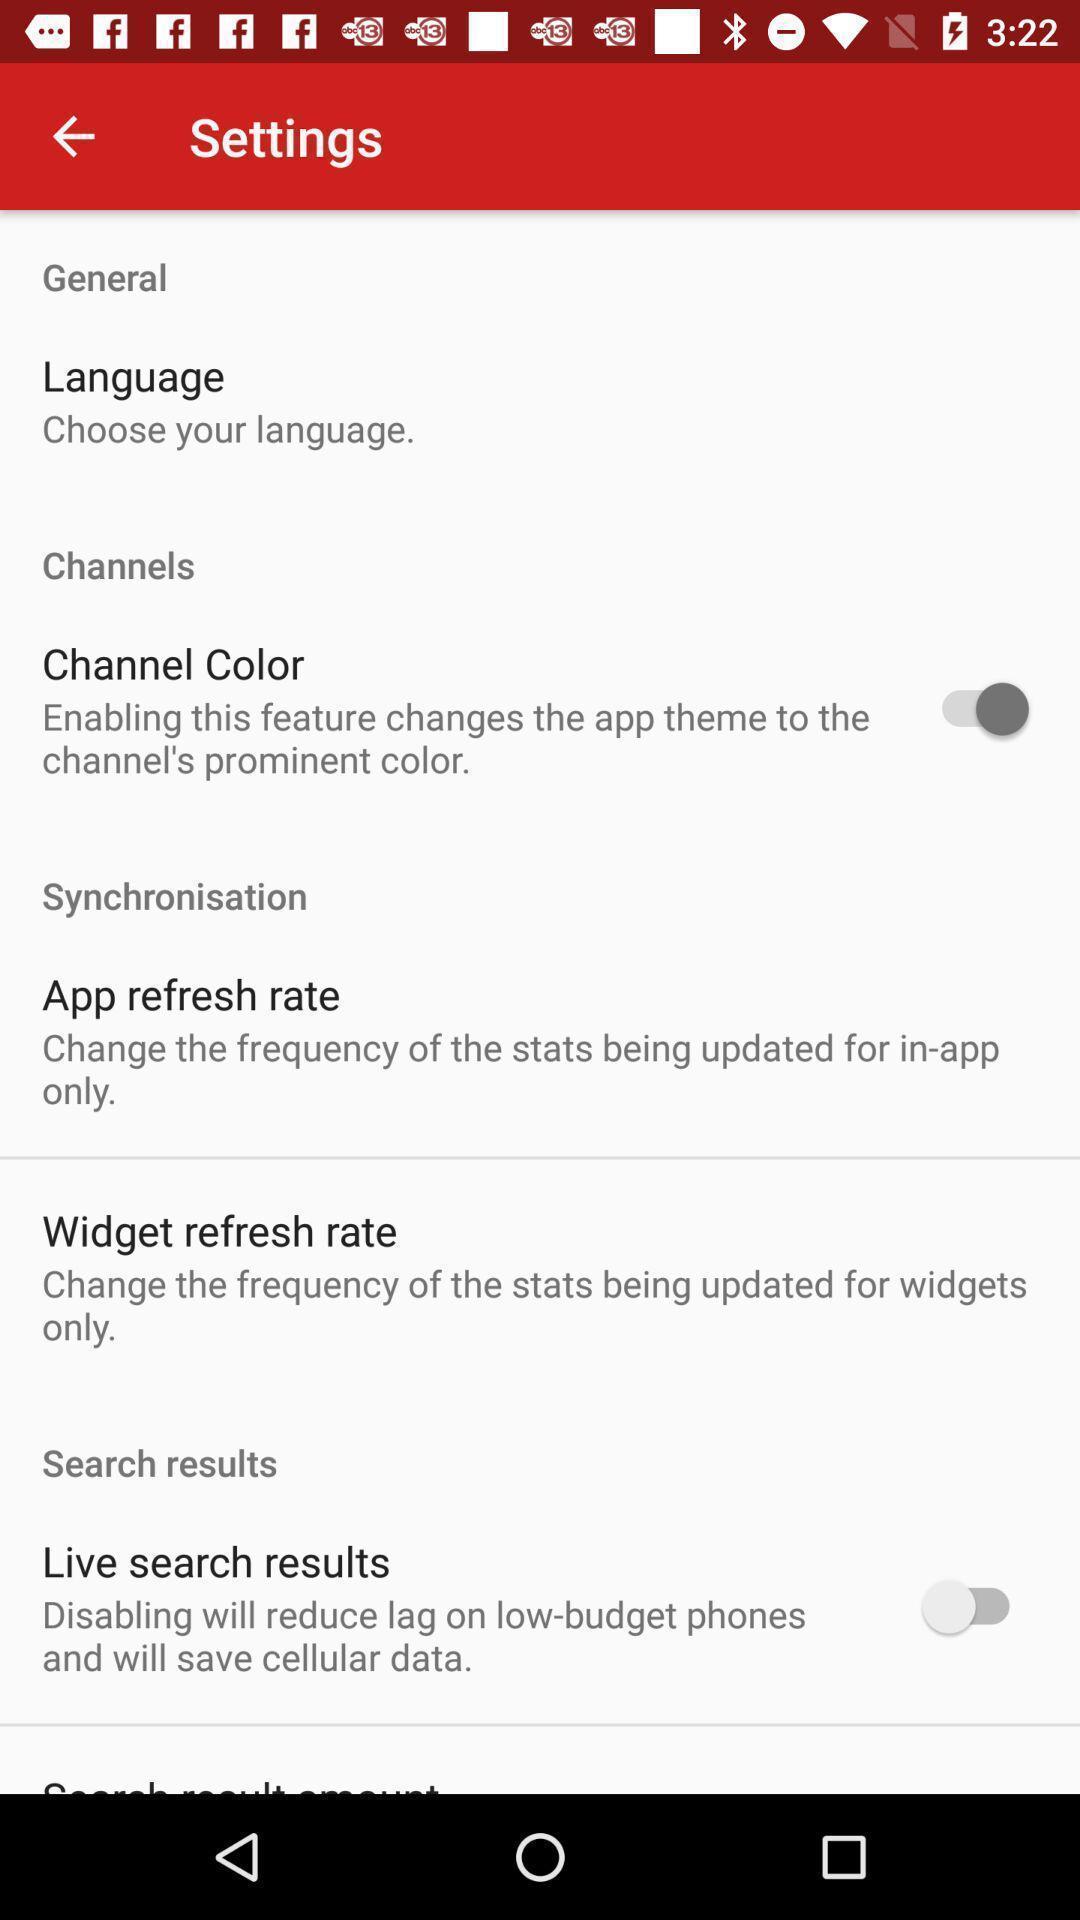Describe the key features of this screenshot. Settings page. 